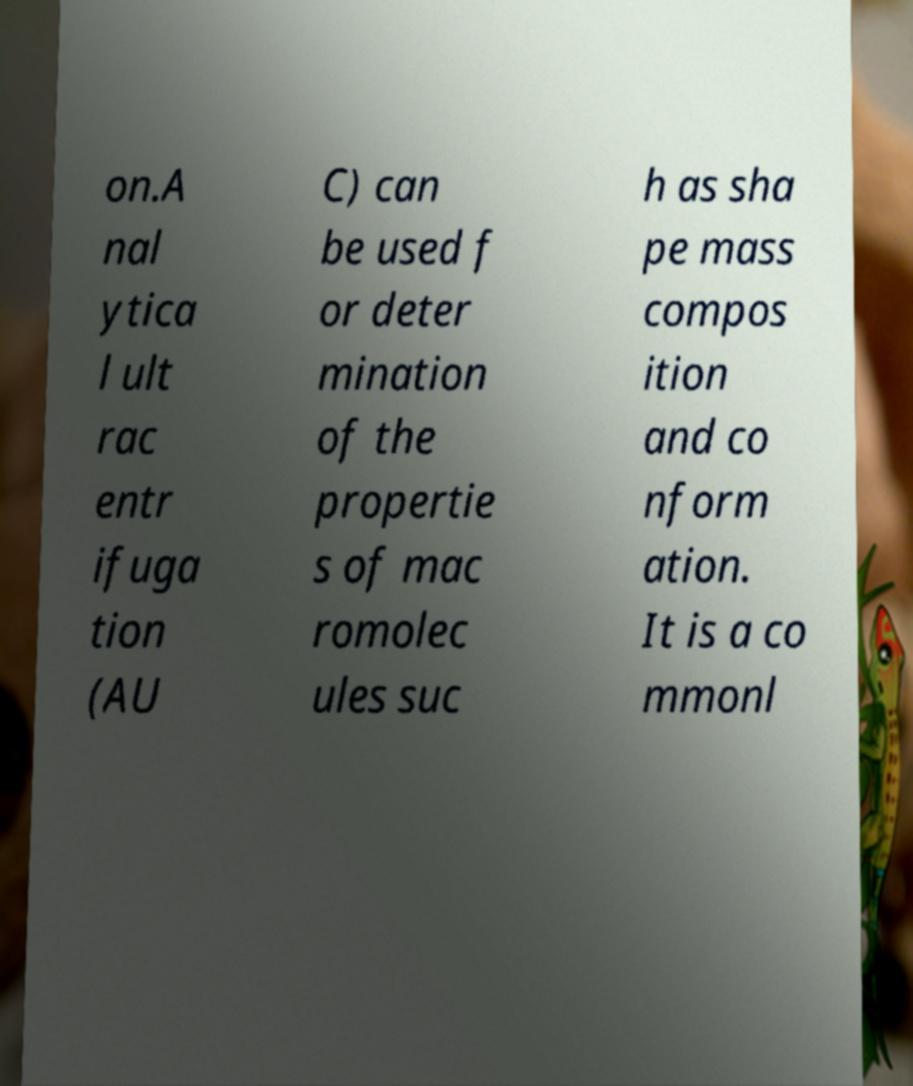Could you extract and type out the text from this image? on.A nal ytica l ult rac entr ifuga tion (AU C) can be used f or deter mination of the propertie s of mac romolec ules suc h as sha pe mass compos ition and co nform ation. It is a co mmonl 